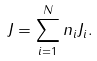Convert formula to latex. <formula><loc_0><loc_0><loc_500><loc_500>J = \sum _ { i = 1 } ^ { N } n _ { i } J _ { i } .</formula> 